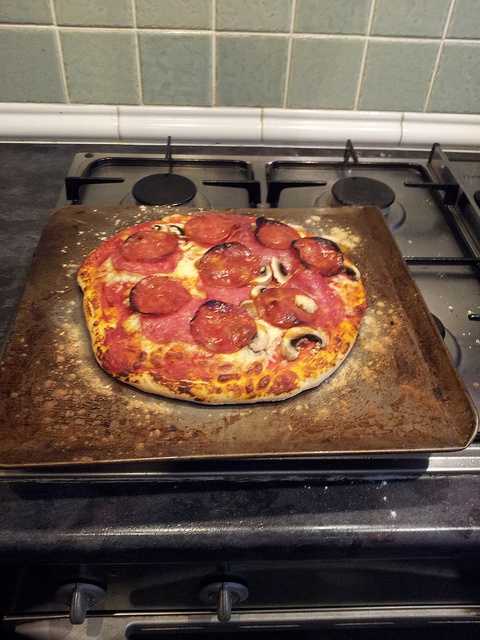Describe the objects in this image and their specific colors. I can see oven in gray, black, and maroon tones and pizza in gray, salmon, brown, red, and orange tones in this image. 